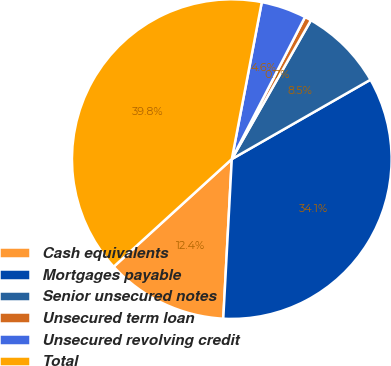Convert chart. <chart><loc_0><loc_0><loc_500><loc_500><pie_chart><fcel>Cash equivalents<fcel>Mortgages payable<fcel>Senior unsecured notes<fcel>Unsecured term loan<fcel>Unsecured revolving credit<fcel>Total<nl><fcel>12.39%<fcel>34.12%<fcel>8.48%<fcel>0.67%<fcel>4.57%<fcel>39.76%<nl></chart> 